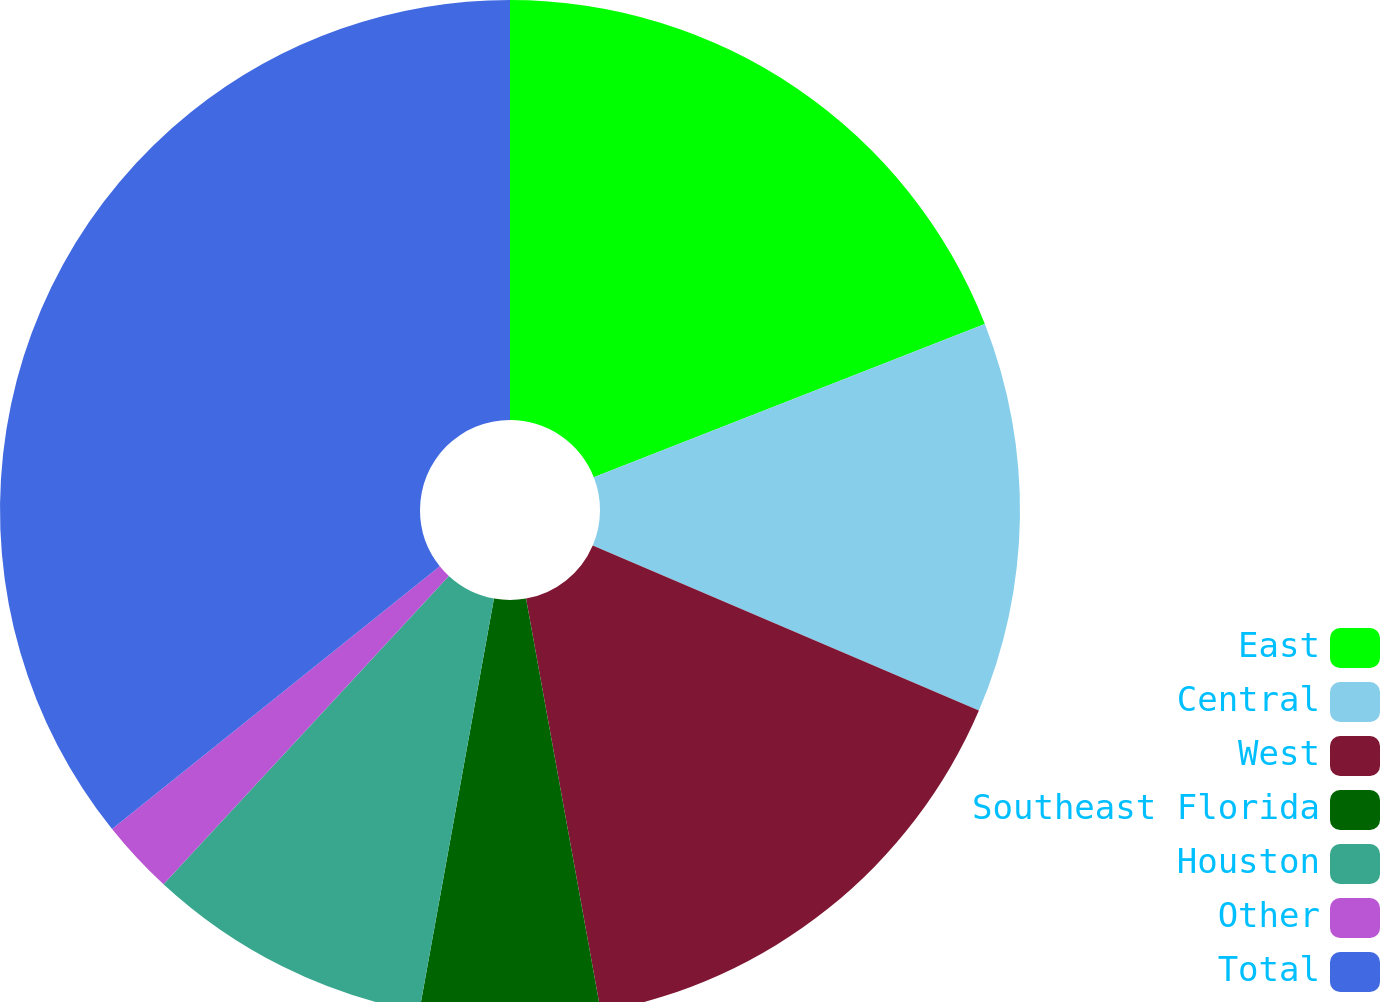<chart> <loc_0><loc_0><loc_500><loc_500><pie_chart><fcel>East<fcel>Central<fcel>West<fcel>Southeast Florida<fcel>Houston<fcel>Other<fcel>Total<nl><fcel>19.06%<fcel>12.38%<fcel>15.72%<fcel>5.7%<fcel>9.04%<fcel>2.36%<fcel>35.76%<nl></chart> 